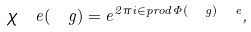<formula> <loc_0><loc_0><loc_500><loc_500>\chi _ { \ } e ( \ g ) = e ^ { 2 \pi i \in p r o d { \Phi ( \ g ) } { \ e } } ,</formula> 